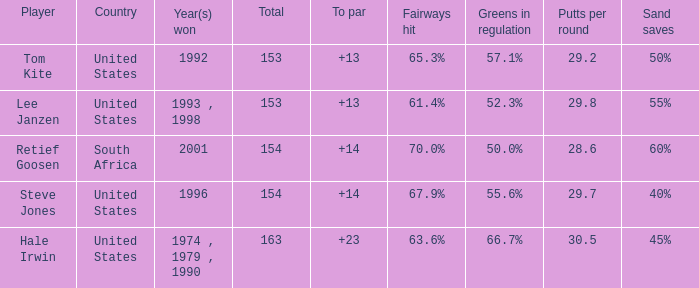What is the highest to par that is less than 153 None. 